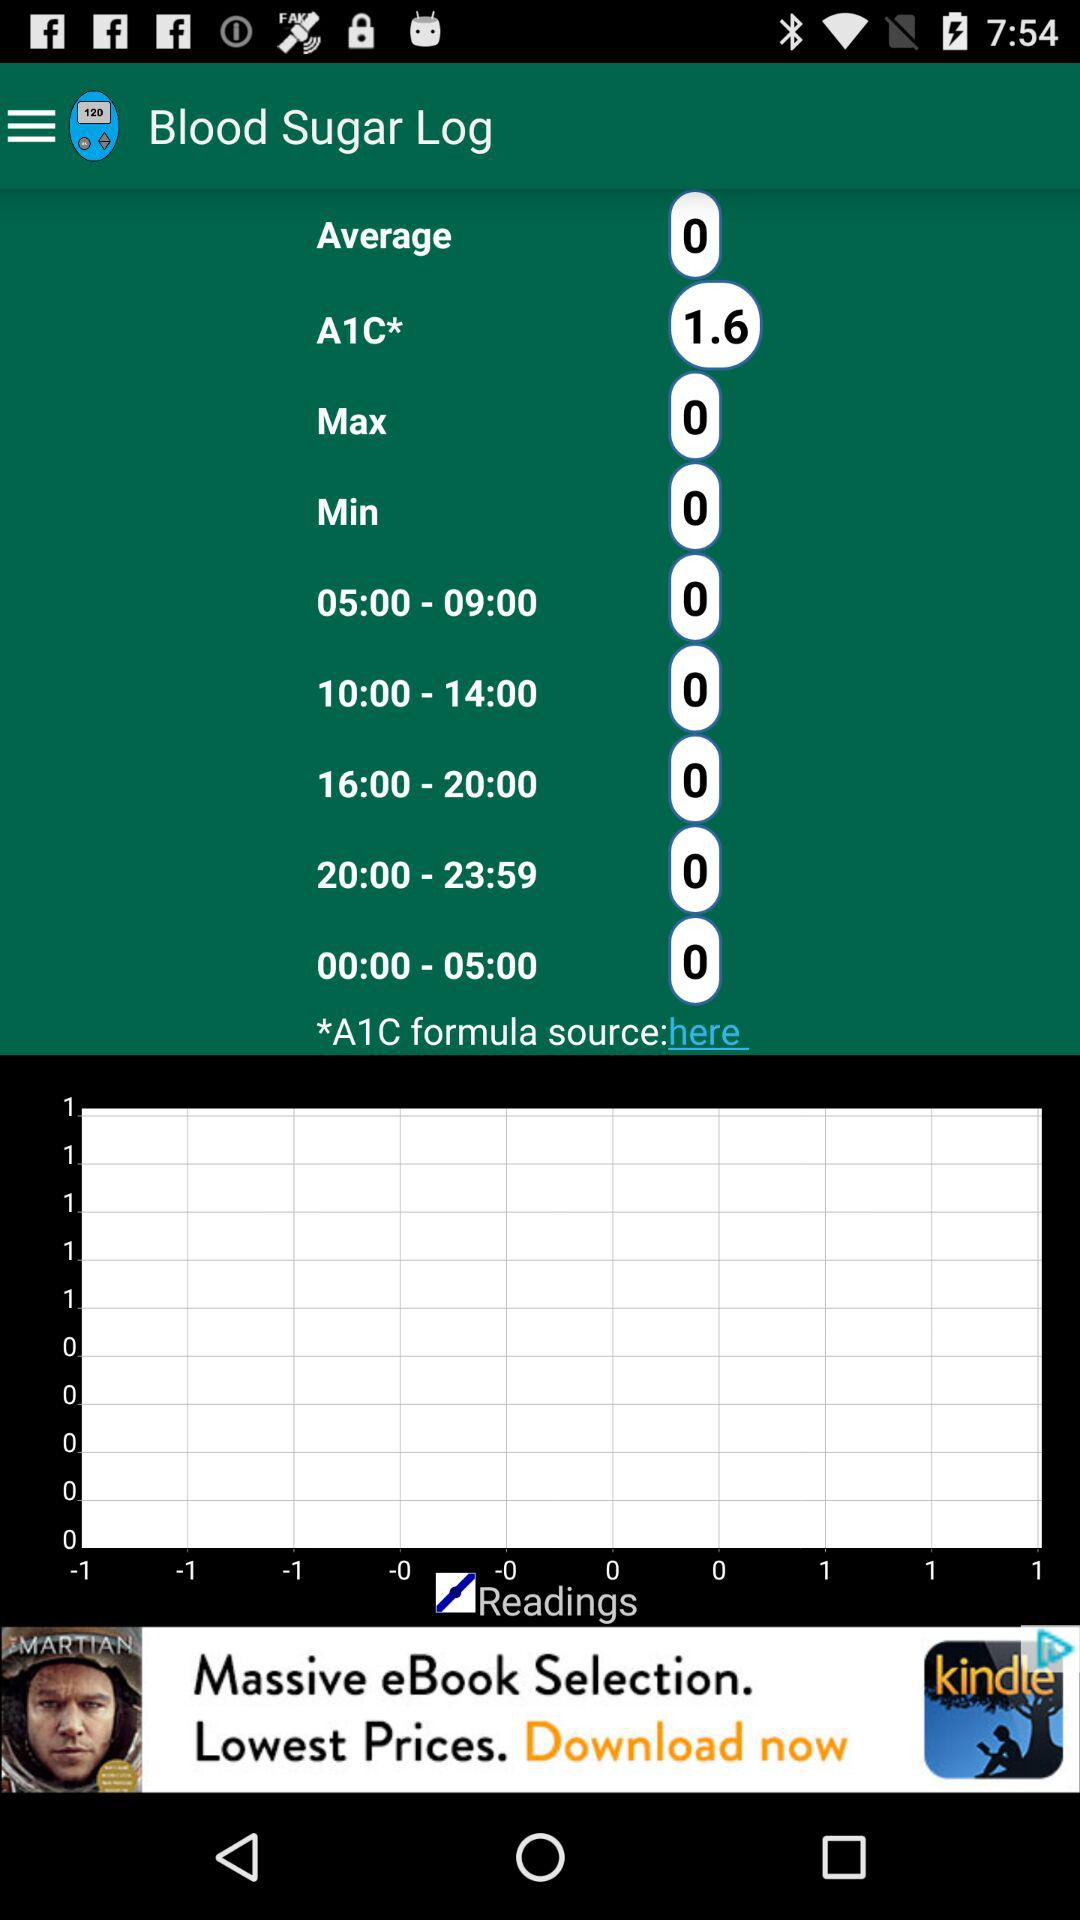What is the average blood sugar level? The average blood sugar level is 0. 